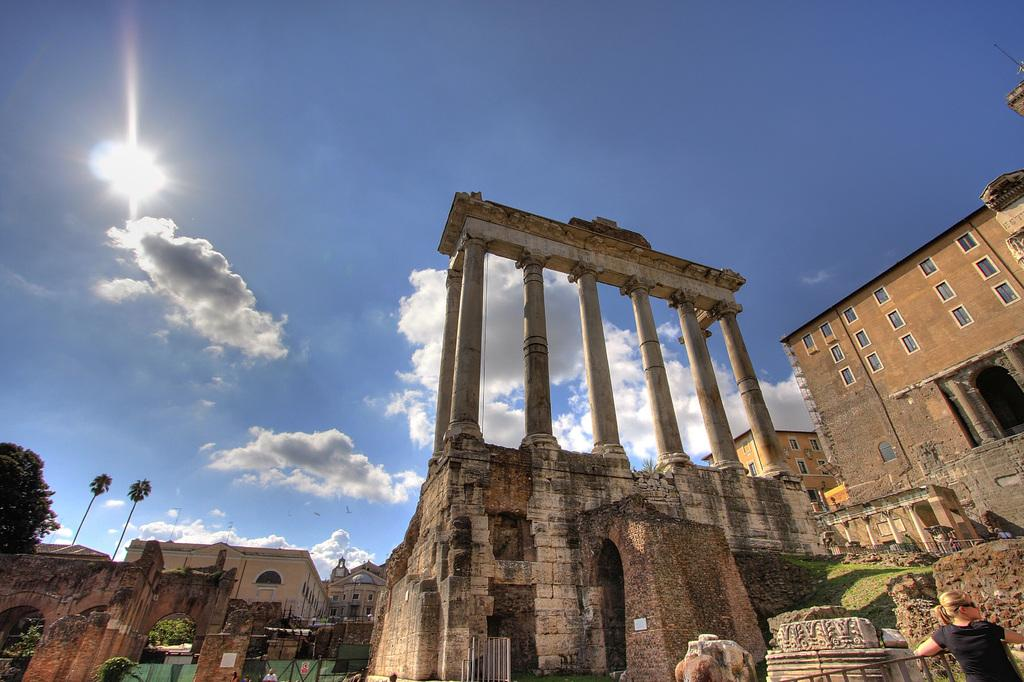What is the main subject of the image? There is a woman standing in the image. What architectural features can be seen in the image? There is a fence, pillars, a wall, and buildings visible in the image. What type of vegetation is present in the image? There are trees in the image. What can be seen in the background of the image? The sky is visible in the background of the image, with clouds present. What other elements are present in the image? There are windows visible in the image. What type of magic is the woman performing in the image? There is no indication of magic or any magical activity in the image. What event is taking place in the image? The image does not depict a specific event; it simply shows a woman standing with various architectural and natural elements in the background. 